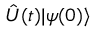<formula> <loc_0><loc_0><loc_500><loc_500>{ \hat { U } } ( t ) | \psi ( 0 ) \rangle</formula> 